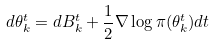Convert formula to latex. <formula><loc_0><loc_0><loc_500><loc_500>d \theta _ { k } ^ { t } = d B _ { k } ^ { t } + \frac { 1 } { 2 } \nabla \log \pi ( \theta _ { k } ^ { t } ) d t</formula> 